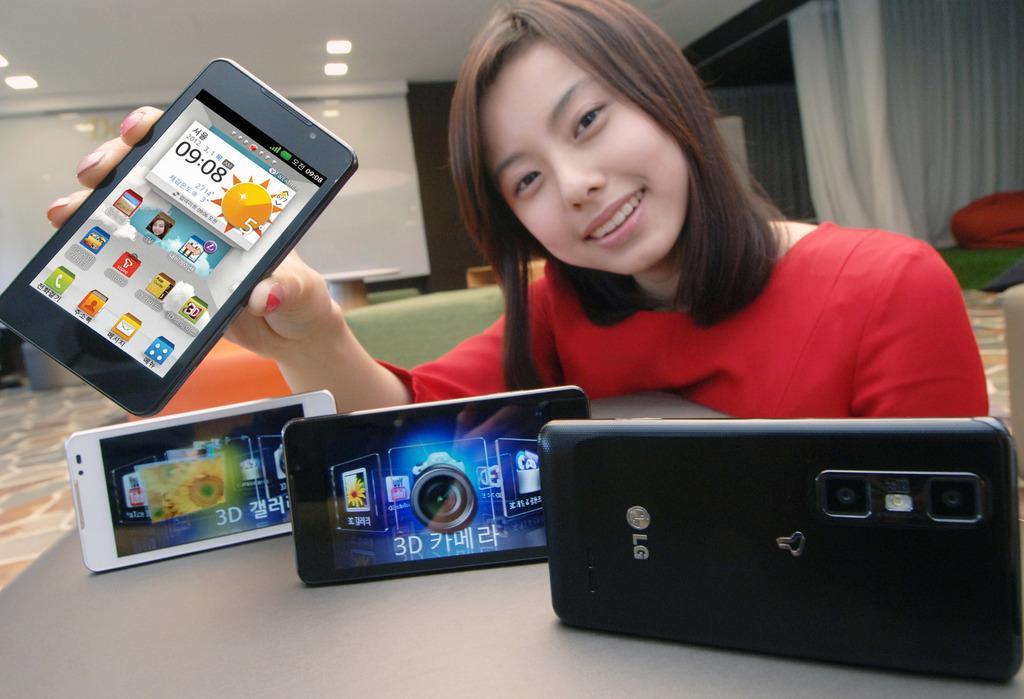In one or two sentences, can you explain what this image depicts? Top right side of the image a woman sitting on a chair. In front of her there is a table on the table there are some mobile phones and she is holding a mobile phone. Top left of the image there is a roof on the roof there are some lights. In the middle of the image there is a wall. Top right side of the image there is a curtain. 